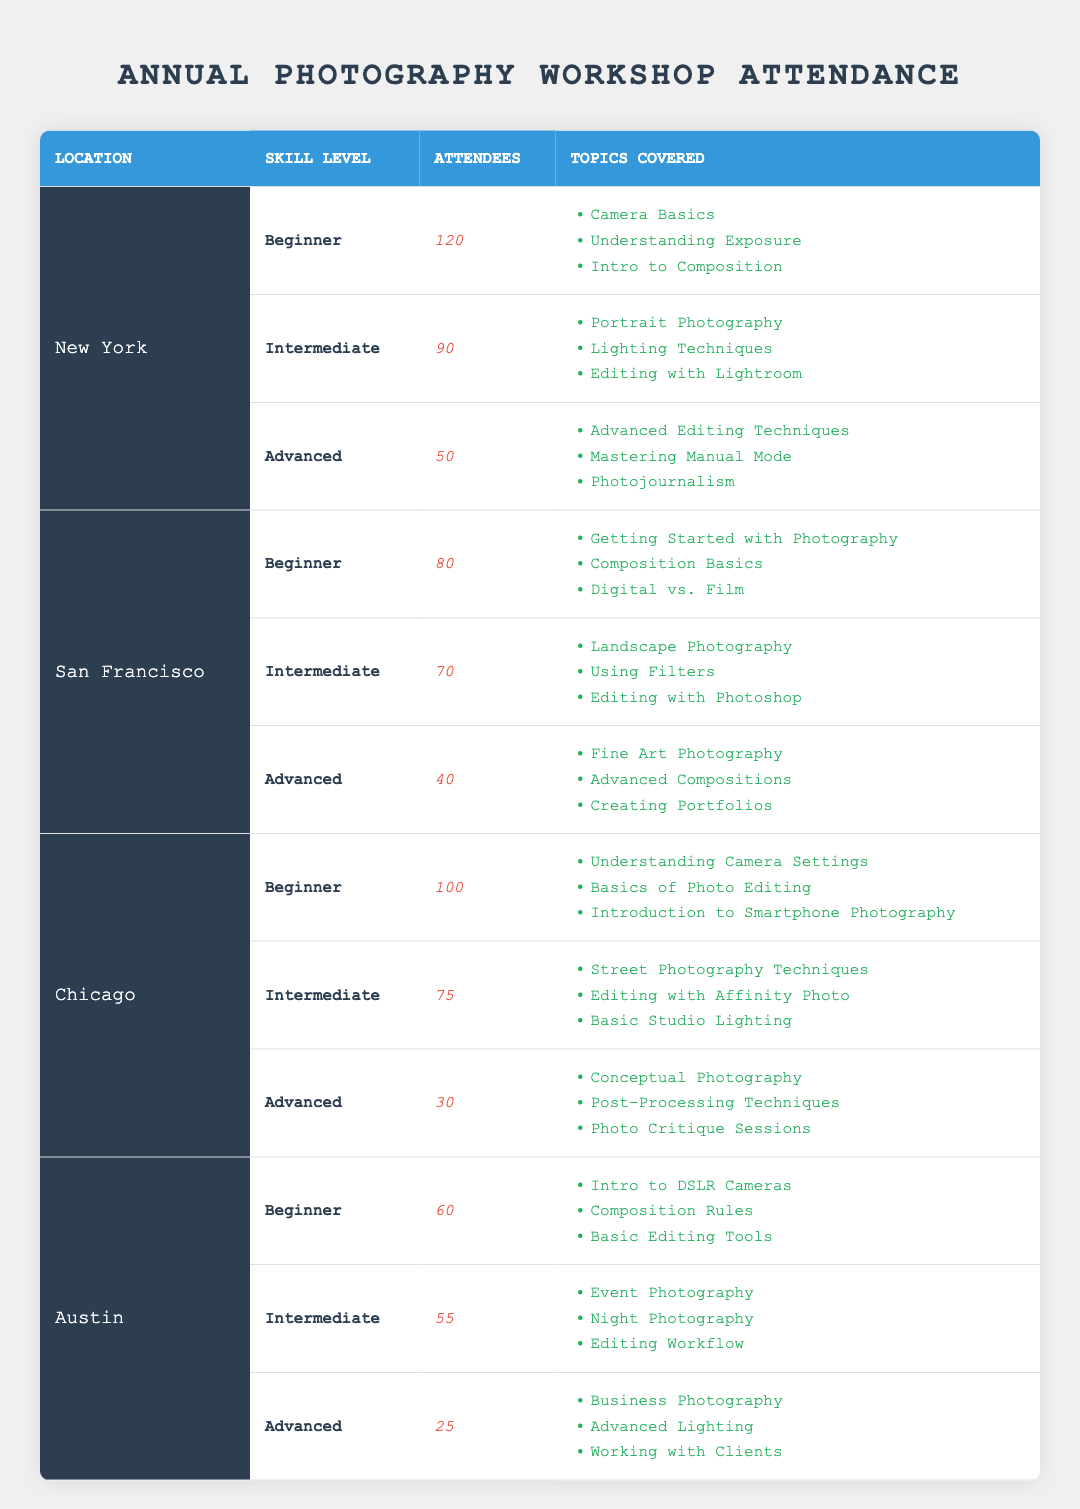What city has the highest number of attendees in the Advanced skill level? The Advanced skill levels for each city show 50 in New York, 40 in San Francisco, 30 in Chicago, and 25 in Austin. New York has the highest number with 50 attendees.
Answer: New York How many more attendees were there in Beginner workshops in Chicago compared to Austin? Chicago had 100 attendees and Austin had 60 attendees in Beginner workshops. The difference is 100 - 60 = 40 attendees.
Answer: 40 Which location has the least number of attendees in Intermediate workshops? Looking at the Intermediate workshops: New York has 90, San Francisco has 70, Chicago has 75, and Austin has 55. Austin has the least with 55 attendees.
Answer: Austin What is the total number of attendees across all locations in Beginner workshops? Adding up the attendees in Beginner workshops: 120 from New York, 80 from San Francisco, 100 from Chicago, and 60 from Austin gives a total of 120 + 80 + 100 + 60 = 360 attendees.
Answer: 360 Is the statement true or false: The total number of Advanced attendees in San Francisco is greater than the total in Chicago? The Advanced attendees in San Francisco are 40 and in Chicago are 30. Since 40 is greater than 30, the statement is true.
Answer: True What is the average number of attendees in Intermediate workshops across all locations? The attendees in Intermediate workshops are 90 in New York, 70 in San Francisco, 75 in Chicago, and 55 in Austin. The total of attendees is 90 + 70 + 75 + 55 = 290. Dividing by 4 locations gives an average of 290 / 4 = 72.5.
Answer: 72.5 Which skill level had the highest total attendance across all locations? Summing the attendees by skill level: Beginner has 120 + 80 + 100 + 60 = 360, Intermediate has 90 + 70 + 75 + 55 = 290, and Advanced has 50 + 40 + 30 + 25 = 145. Beginner has the highest total with 360.
Answer: Beginner How many attendees were there in total for Advanced workshops, and which city contributed the most? The Advanced attendees are 50 in New York, 40 in San Francisco, 30 in Chicago, and 25 in Austin. The total is 50 + 40 + 30 + 25 = 145. New York contributed the most with 50 attendees.
Answer: 145, New York 